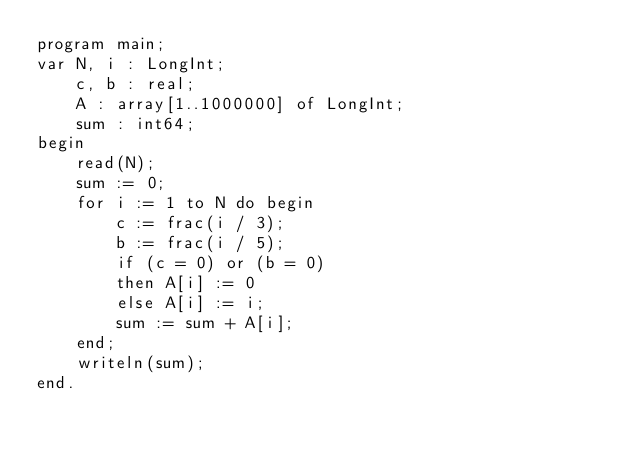Convert code to text. <code><loc_0><loc_0><loc_500><loc_500><_Pascal_>program main;
var N, i : LongInt;
    c, b : real;
    A : array[1..1000000] of LongInt;
    sum : int64;
begin
	read(N);
    sum := 0;
    for i := 1 to N do begin
        c := frac(i / 3);
        b := frac(i / 5);
        if (c = 0) or (b = 0)
        then A[i] := 0
        else A[i] := i;
        sum := sum + A[i];
    end;
    writeln(sum);
end.</code> 